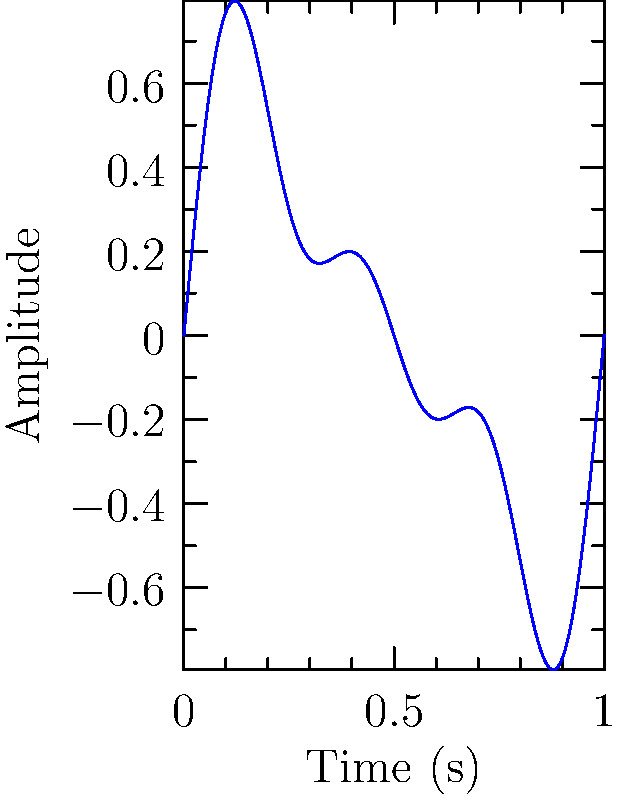Analyze the waveform shown above, which represents the percussion section of a song. What is the fundamental frequency of this waveform, given that the time axis spans 1 second? To determine the fundamental frequency of the waveform, we need to follow these steps:

1. Observe the waveform: The graph shows a complex wave that repeats once over the 1-second time span.

2. Identify the period: The period (T) of the fundamental frequency is the time it takes for one complete cycle of the wave. In this case, T = 1 second.

3. Calculate the frequency: The fundamental frequency (f) is the reciprocal of the period. We can use the formula:

   $$f = \frac{1}{T}$$

4. Plug in the values:
   $$f = \frac{1}{1\text{ s}} = 1\text{ Hz}$$

5. Interpret the result: The fundamental frequency of the waveform is 1 Hz, meaning the basic rhythm of this percussion section repeats once per second.

Note: The waveform also shows higher frequency components (harmonics) that give the sound its unique timbre, but the fundamental frequency corresponds to the lowest and most prominent periodic component.
Answer: 1 Hz 